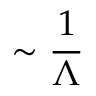<formula> <loc_0><loc_0><loc_500><loc_500>\sim \frac { 1 } { \Lambda }</formula> 